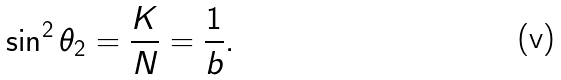<formula> <loc_0><loc_0><loc_500><loc_500>\sin ^ { 2 } \theta _ { 2 } = \frac { K } { N } = \frac { 1 } { b } .</formula> 